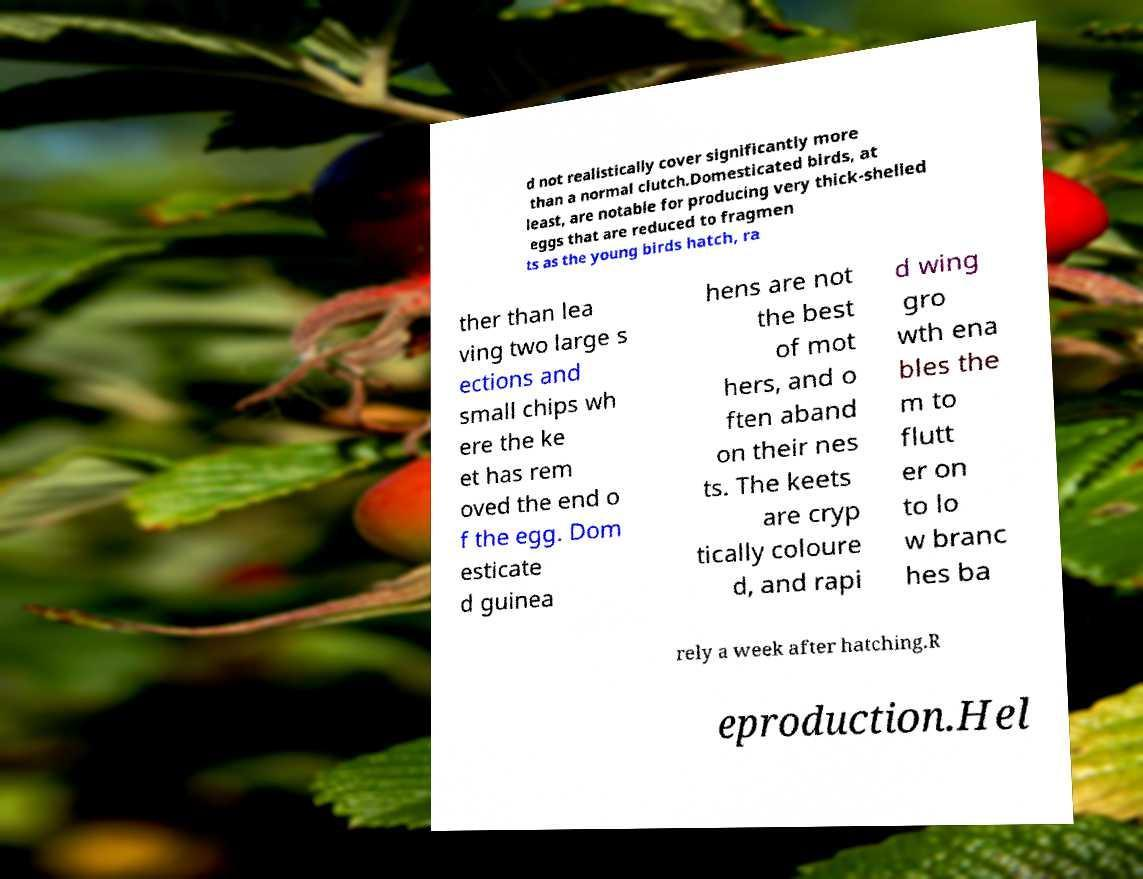Can you read and provide the text displayed in the image?This photo seems to have some interesting text. Can you extract and type it out for me? d not realistically cover significantly more than a normal clutch.Domesticated birds, at least, are notable for producing very thick-shelled eggs that are reduced to fragmen ts as the young birds hatch, ra ther than lea ving two large s ections and small chips wh ere the ke et has rem oved the end o f the egg. Dom esticate d guinea hens are not the best of mot hers, and o ften aband on their nes ts. The keets are cryp tically coloure d, and rapi d wing gro wth ena bles the m to flutt er on to lo w branc hes ba rely a week after hatching.R eproduction.Hel 